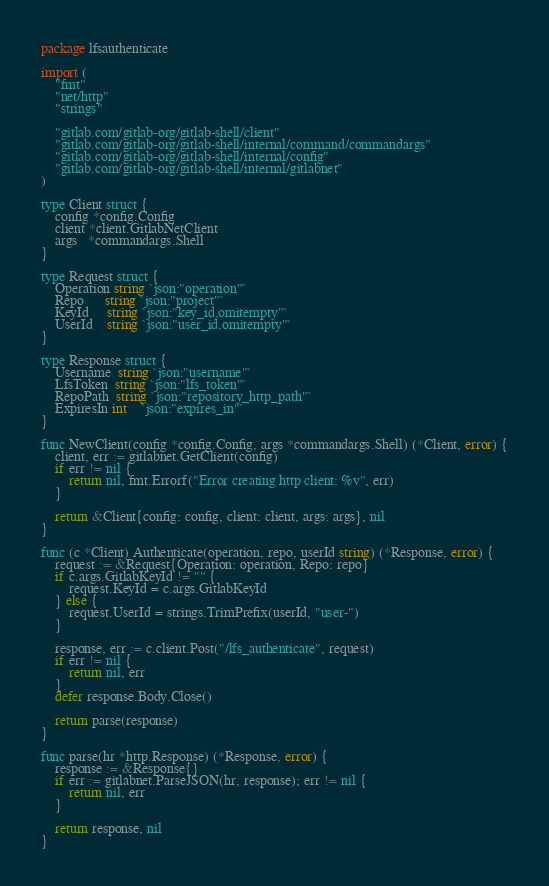<code> <loc_0><loc_0><loc_500><loc_500><_Go_>package lfsauthenticate

import (
	"fmt"
	"net/http"
	"strings"

	"gitlab.com/gitlab-org/gitlab-shell/client"
	"gitlab.com/gitlab-org/gitlab-shell/internal/command/commandargs"
	"gitlab.com/gitlab-org/gitlab-shell/internal/config"
	"gitlab.com/gitlab-org/gitlab-shell/internal/gitlabnet"
)

type Client struct {
	config *config.Config
	client *client.GitlabNetClient
	args   *commandargs.Shell
}

type Request struct {
	Operation string `json:"operation"`
	Repo      string `json:"project"`
	KeyId     string `json:"key_id,omitempty"`
	UserId    string `json:"user_id,omitempty"`
}

type Response struct {
	Username  string `json:"username"`
	LfsToken  string `json:"lfs_token"`
	RepoPath  string `json:"repository_http_path"`
	ExpiresIn int    `json:"expires_in"`
}

func NewClient(config *config.Config, args *commandargs.Shell) (*Client, error) {
	client, err := gitlabnet.GetClient(config)
	if err != nil {
		return nil, fmt.Errorf("Error creating http client: %v", err)
	}

	return &Client{config: config, client: client, args: args}, nil
}

func (c *Client) Authenticate(operation, repo, userId string) (*Response, error) {
	request := &Request{Operation: operation, Repo: repo}
	if c.args.GitlabKeyId != "" {
		request.KeyId = c.args.GitlabKeyId
	} else {
		request.UserId = strings.TrimPrefix(userId, "user-")
	}

	response, err := c.client.Post("/lfs_authenticate", request)
	if err != nil {
		return nil, err
	}
	defer response.Body.Close()

	return parse(response)
}

func parse(hr *http.Response) (*Response, error) {
	response := &Response{}
	if err := gitlabnet.ParseJSON(hr, response); err != nil {
		return nil, err
	}

	return response, nil
}
</code> 